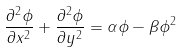Convert formula to latex. <formula><loc_0><loc_0><loc_500><loc_500>\frac { \partial ^ { 2 } \phi } { \partial x ^ { 2 } } + \frac { \partial ^ { 2 } \phi } { \partial y ^ { 2 } } = \alpha \phi - \beta \phi ^ { 2 }</formula> 